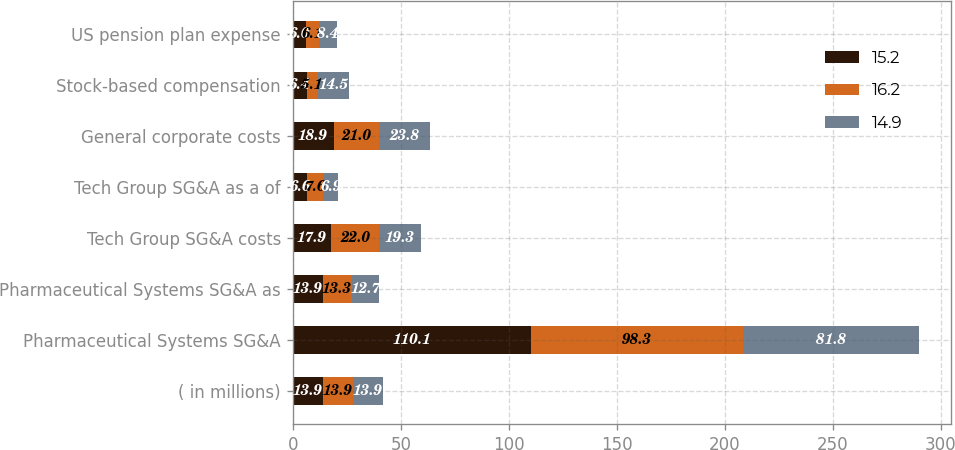Convert chart to OTSL. <chart><loc_0><loc_0><loc_500><loc_500><stacked_bar_chart><ecel><fcel>( in millions)<fcel>Pharmaceutical Systems SG&A<fcel>Pharmaceutical Systems SG&A as<fcel>Tech Group SG&A costs<fcel>Tech Group SG&A as a of<fcel>General corporate costs<fcel>Stock-based compensation<fcel>US pension plan expense<nl><fcel>15.2<fcel>13.9<fcel>110.1<fcel>13.9<fcel>17.9<fcel>6.6<fcel>18.9<fcel>6.4<fcel>6<nl><fcel>16.2<fcel>13.9<fcel>98.3<fcel>13.3<fcel>22<fcel>7.6<fcel>21<fcel>5.1<fcel>6.1<nl><fcel>14.9<fcel>13.9<fcel>81.8<fcel>12.7<fcel>19.3<fcel>6.9<fcel>23.8<fcel>14.5<fcel>8.4<nl></chart> 